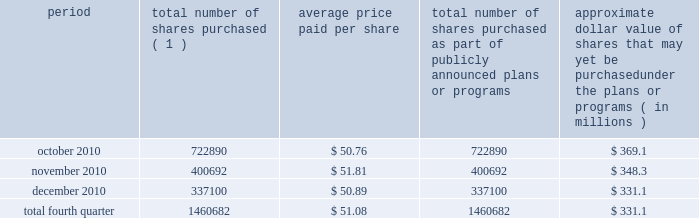Issuer purchases of equity securities during the three months ended december 31 , 2010 , we repurchased 1460682 shares of our common stock for an aggregate of $ 74.6 million , including commissions and fees , pursuant to our publicly announced stock repurchase program , as follows : period total number of shares purchased ( 1 ) average price paid per share total number of shares purchased as part of publicly announced plans or programs approximate dollar value of shares that may yet be purchased under the plans or programs ( in millions ) .
( 1 ) repurchases made pursuant to the $ 1.5 billion stock repurchase program approved by our board of directors in february 2008 ( the 201cbuyback 201d ) .
Under this program , our management is authorized to purchase shares from time to time through open market purchases or privately negotiated transactions at prevailing prices as permitted by securities laws and other legal requirements , and subject to market conditions and other factors .
To facilitate repurchases , we make purchases pursuant to trading plans under rule 10b5-1 of the exchange act , which allows us to repurchase shares during periods when we otherwise might be prevented from doing so under insider trading laws or because of self-imposed trading blackout periods .
This program may be discontinued at any time .
Subsequent to december 31 , 2010 , we repurchased 1122481 shares of our common stock for an aggregate of $ 58.0 million , including commissions and fees , pursuant to the buyback .
As of february 11 , 2011 , we had repurchased a total of 30.9 million shares of our common stock for an aggregate of $ 1.2 billion , including commissions and fees pursuant to the buyback .
We expect to continue to manage the pacing of the remaining $ 273.1 million under the buyback in response to general market conditions and other relevant factors. .
What was the weighted average price per share of the shares 30.9 repurchased as of february 11 , 2011? 
Computations: (1.2 / 30.9)
Answer: 0.03883. 